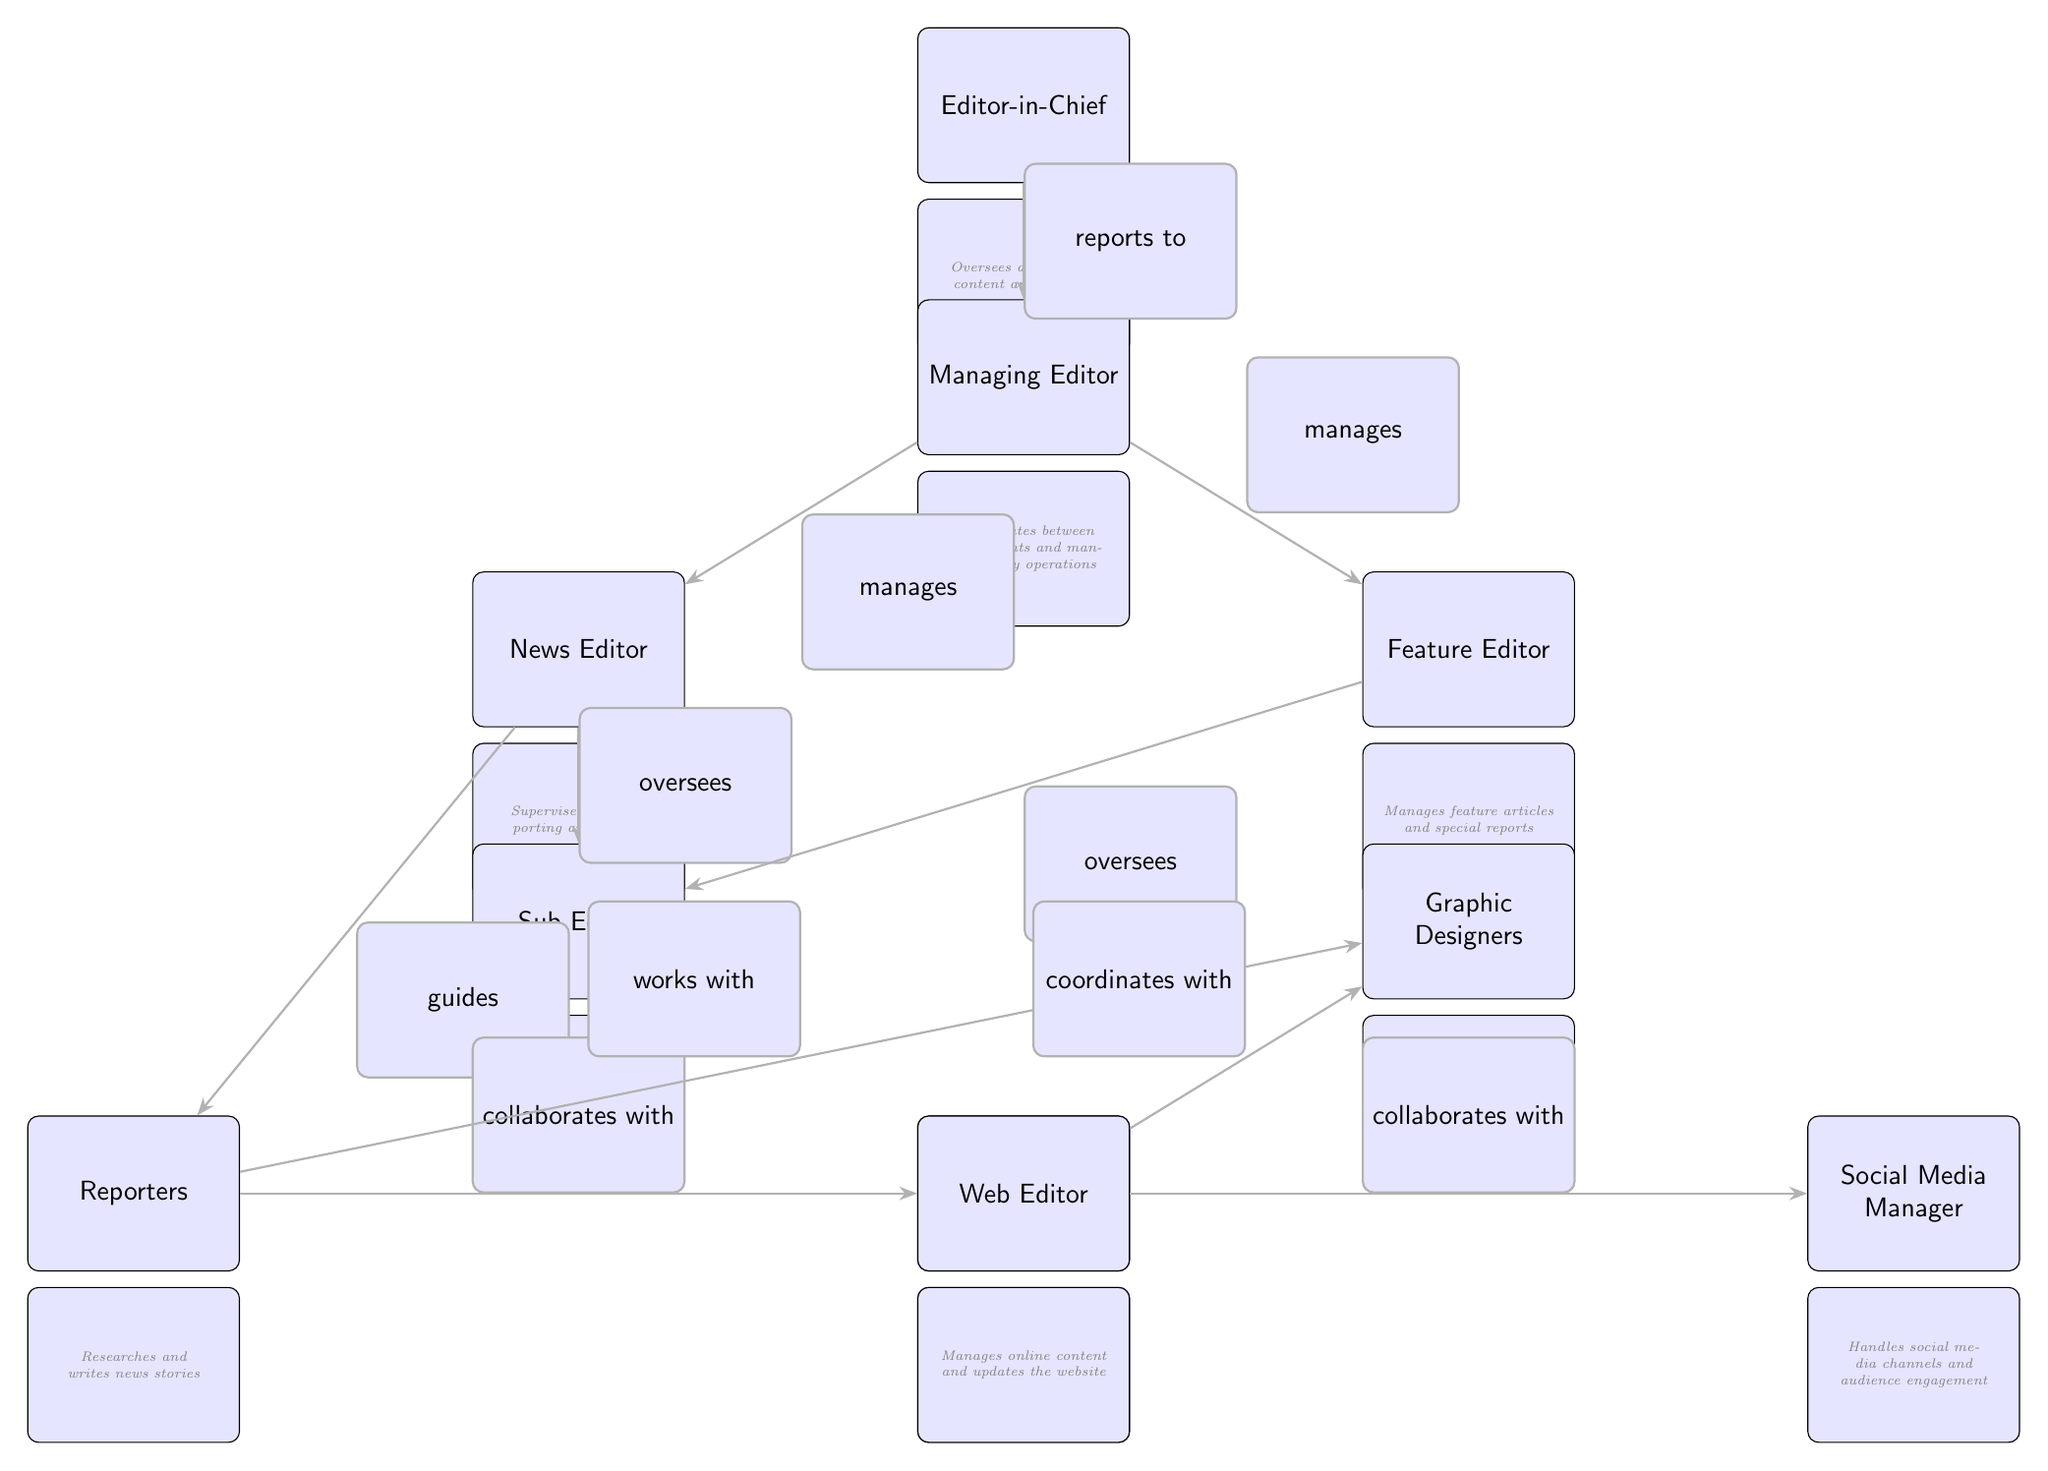What is the top position in the Organizational Chart? The top position is the Editor-in-Chief, as it is the highest node in the diagram controlling all other roles.
Answer: Editor-in-Chief How many editors report to the Managing Editor? The Managing Editor directly manages two editors: the News Editor and the Feature Editor, which is indicated by the direct lines from Managing Editor to these two nodes.
Answer: 2 Who oversees the Sub Editor? The Sub Editor is overseen by both the News Editor and the Feature Editor, as shown by the arrows indicating oversight from both these positions towards the Sub Editor.
Answer: News Editor and Feature Editor What role is responsible for managing online content? The role responsible for managing online content is the Web Editor, directly indicated in the diagram.
Answer: Web Editor What relationship exists between Reporters and Photographers? Reporters collaborate with Photographers, which is directly shown by the line connecting the two nodes with the label "collaborates with."
Answer: collaborates with How many total nodes are present in the chart? Counting all positions including the Editor-in-Chief, there are a total of 8 nodes representing various roles in the editorial team.
Answer: 8 What does the Graphic Designer create? The Graphic Designer creates visual content, which is specified in the description below the node in the diagram.
Answer: Visual content In terms of department management, who does the Managing Editor coordinate with? The Managing Editor coordinates with the News Editor and Feature Editor, as indicated by directional arrows from the Managing Editor to these two roles in the organizational structure.
Answer: News Editor and Feature Editor 